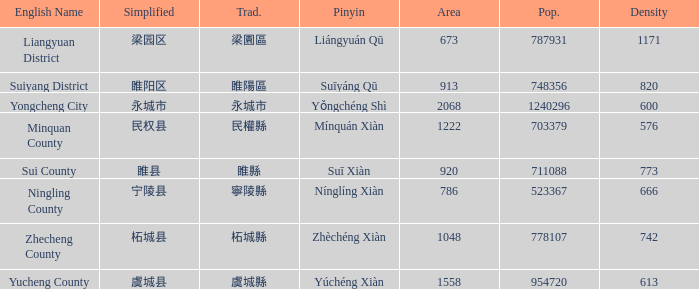How many areas have a population of 703379? 1.0. 